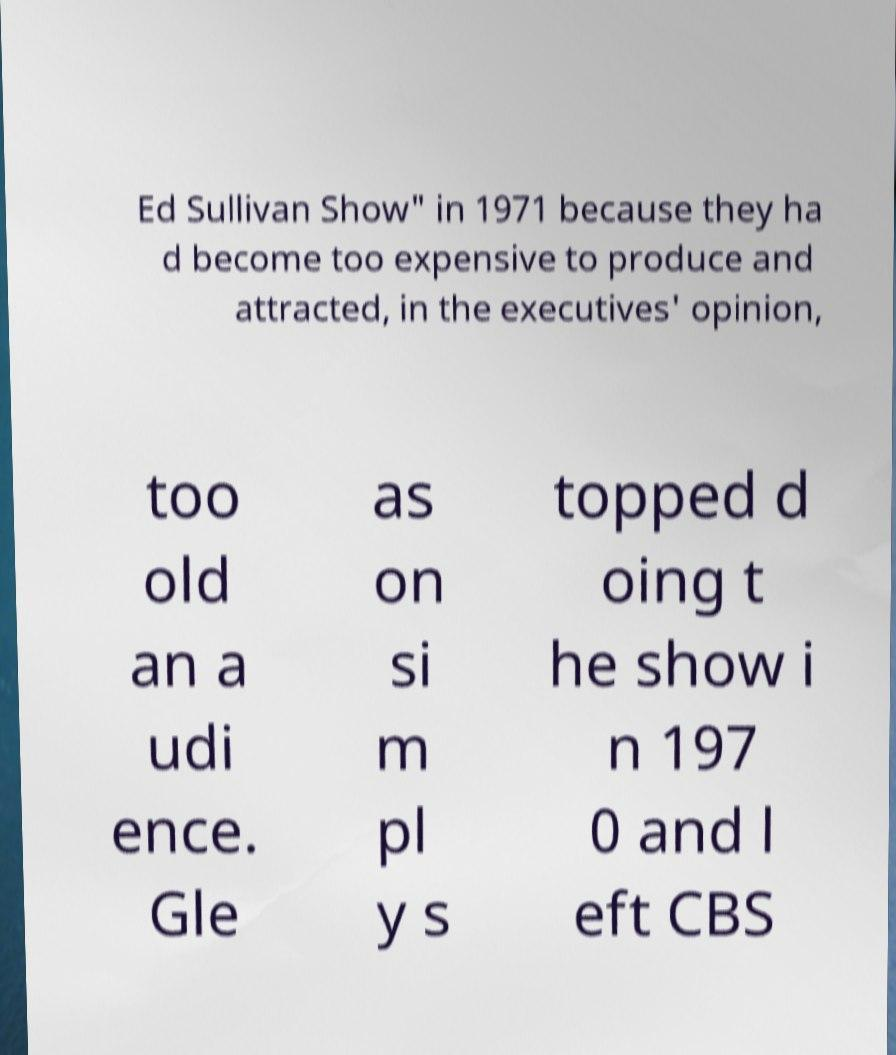Please read and relay the text visible in this image. What does it say? Ed Sullivan Show" in 1971 because they ha d become too expensive to produce and attracted, in the executives' opinion, too old an a udi ence. Gle as on si m pl y s topped d oing t he show i n 197 0 and l eft CBS 